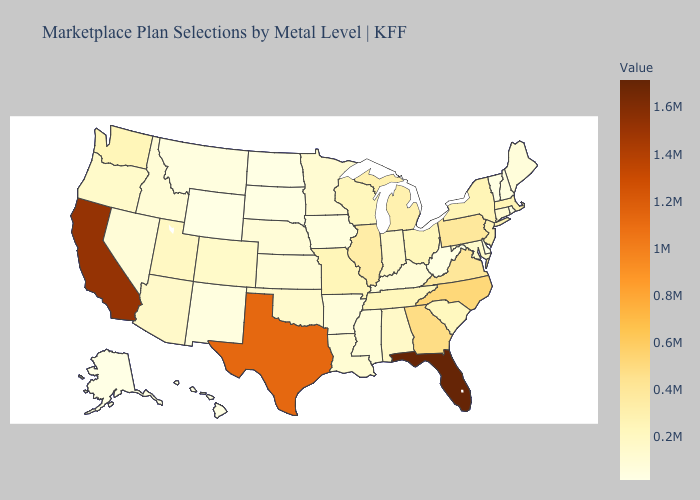Does Massachusetts have a lower value than Nebraska?
Give a very brief answer. No. Does New Jersey have the lowest value in the Northeast?
Be succinct. No. Does Wyoming have the lowest value in the USA?
Short answer required. No. Does Missouri have a lower value than Montana?
Write a very short answer. No. Which states have the lowest value in the USA?
Short answer required. Alaska. 